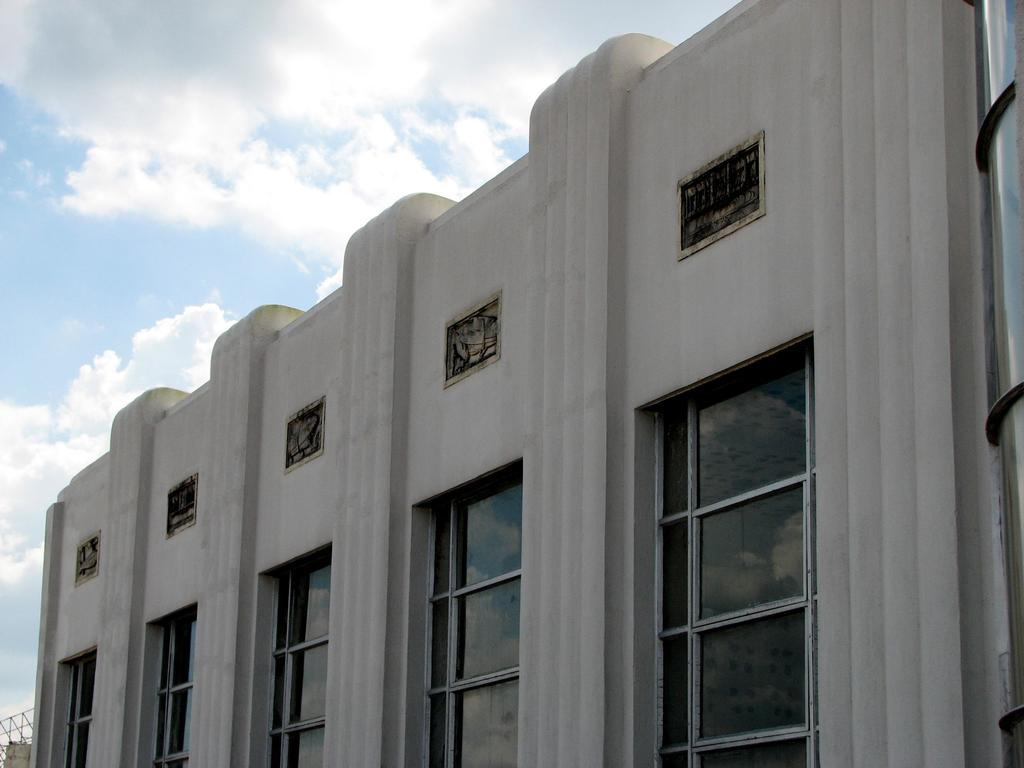What type of structure is visible in the image? There is a building in the image. What is the color of the building? The building is white. What feature can be seen on the building? The building has windows. What can be seen in the background of the image? There are clouds in the background of the image. What is the color of the sky in the image? The sky is blue in the image. How many cakes are being served in the class depicted in the image? There is no class or cakes present in the image; it features a white building with windows and a blue sky with clouds in the background. 